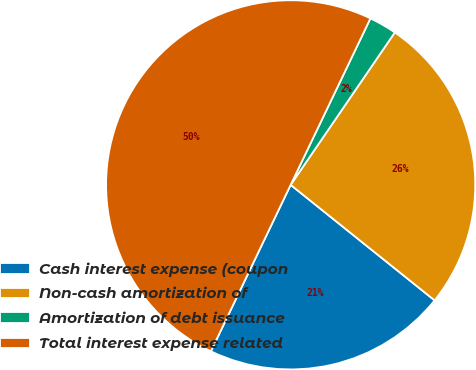Convert chart. <chart><loc_0><loc_0><loc_500><loc_500><pie_chart><fcel>Cash interest expense (coupon<fcel>Non-cash amortization of<fcel>Amortization of debt issuance<fcel>Total interest expense related<nl><fcel>21.35%<fcel>26.22%<fcel>2.43%<fcel>50.0%<nl></chart> 